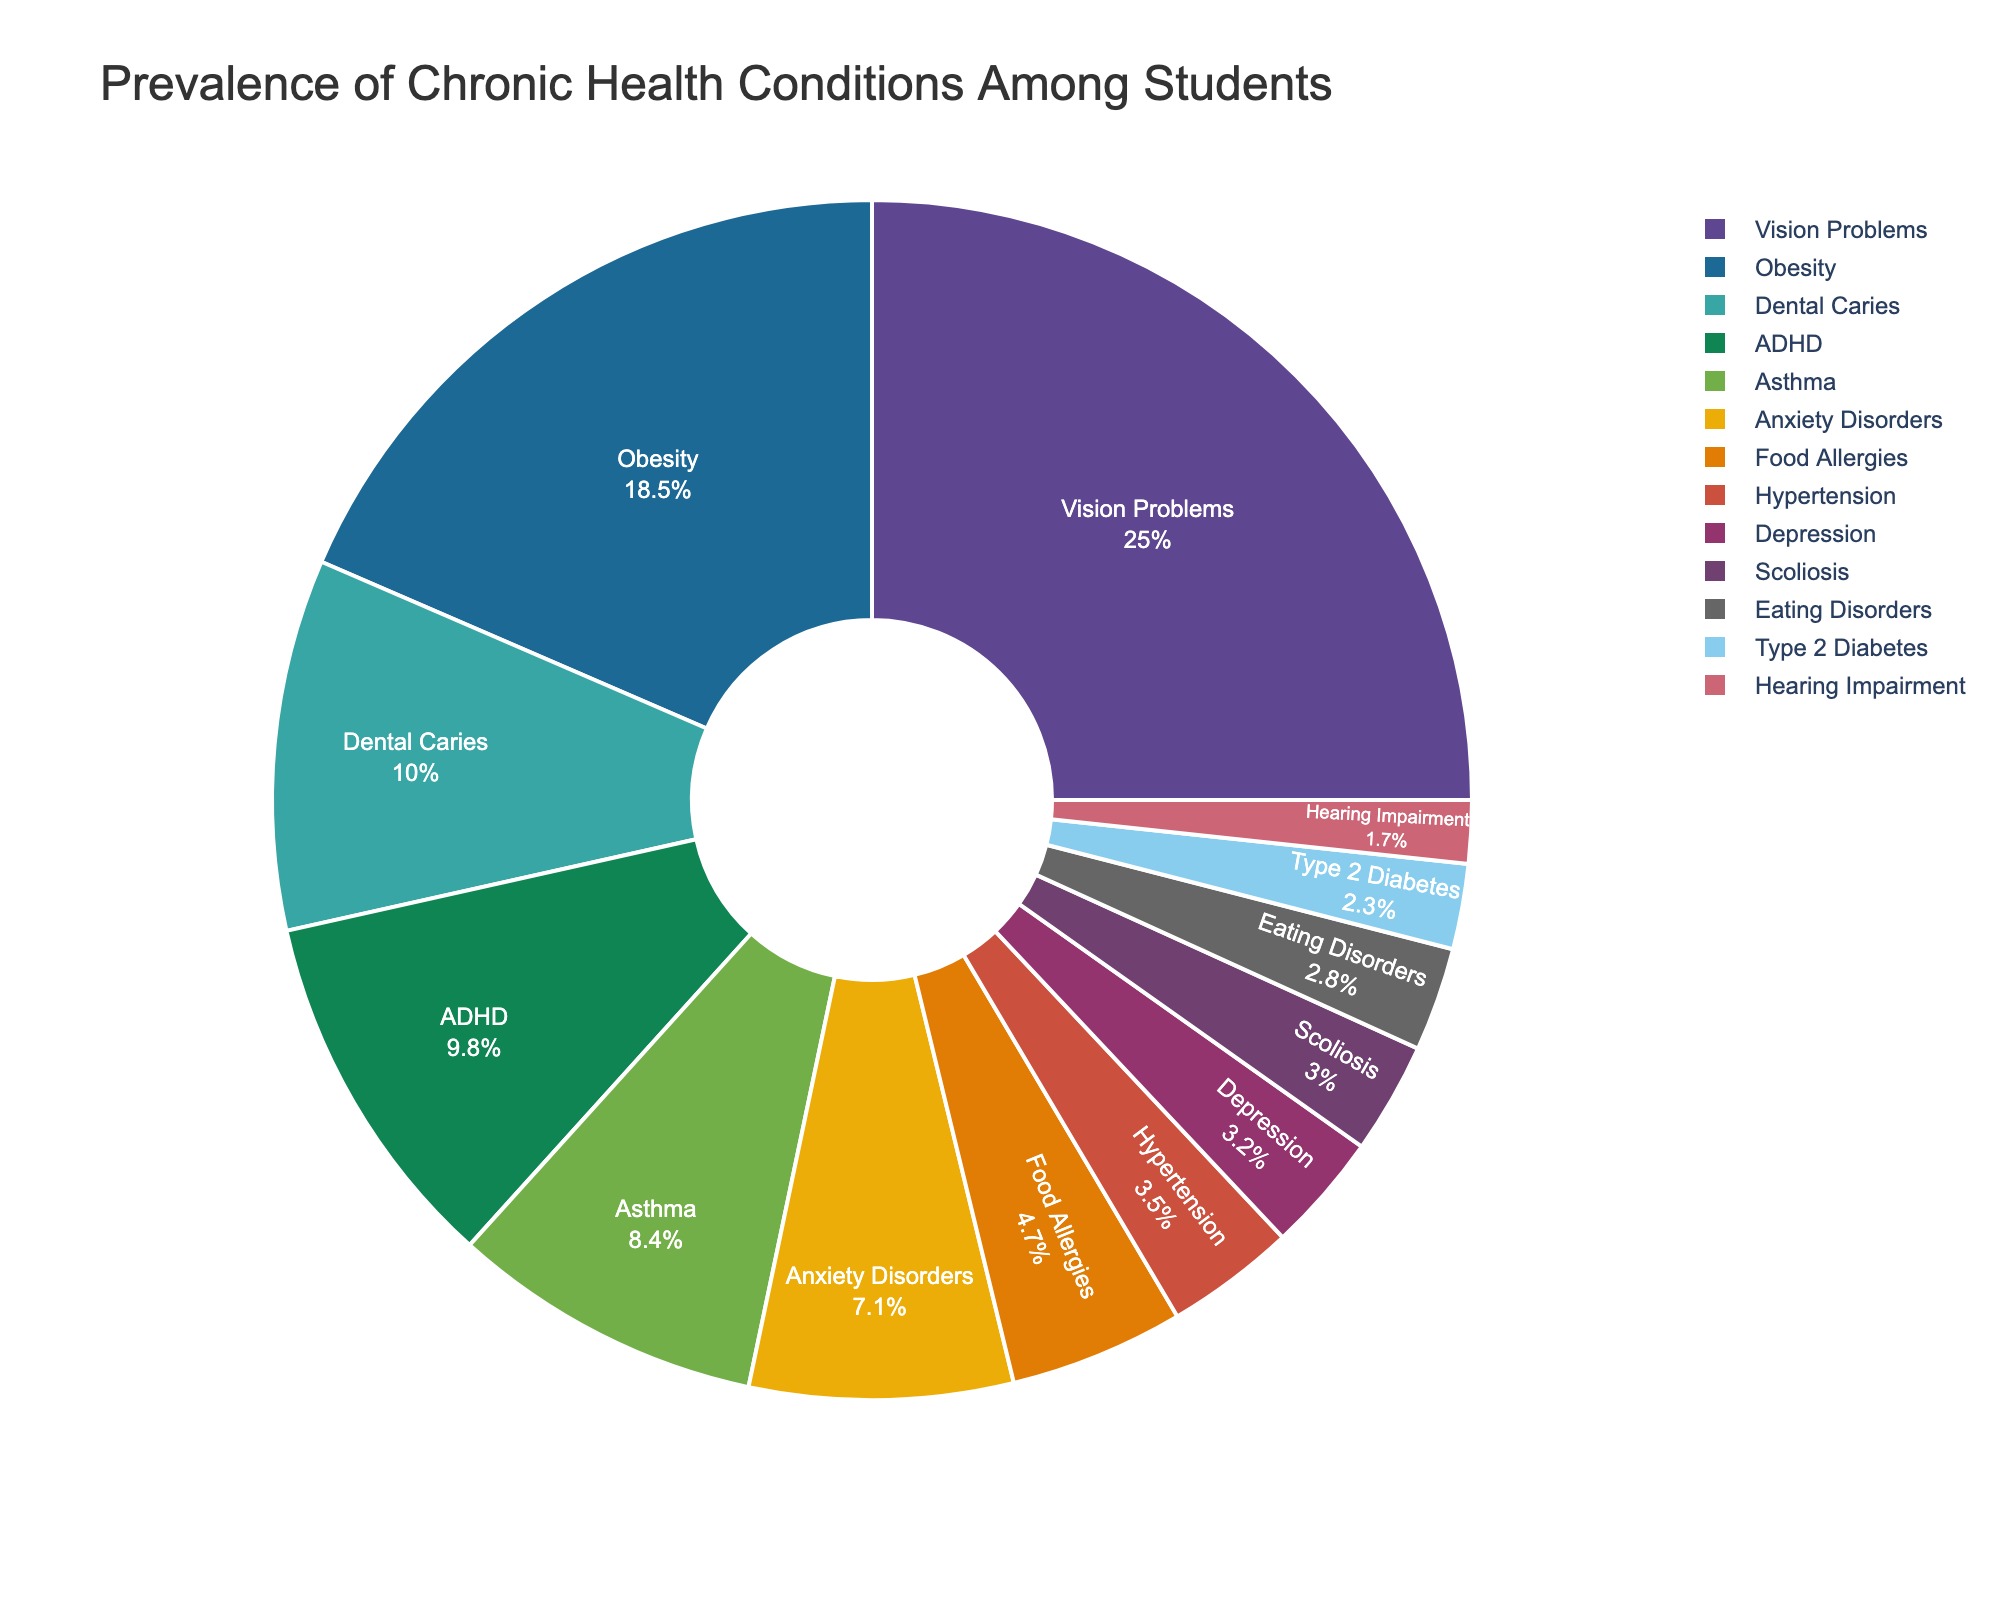Which health condition has the highest prevalence among students? The pie chart shows that the largest segment corresponds to Vision Problems with 25% of the total.
Answer: Vision Problems What is the combined prevalence of Asthma and ADHD among students? The prevalence of Asthma is 8.4% and ADHD is 9.8%. Adding these together results in 8.4 + 9.8 = 18.2%.
Answer: 18.2% Which two conditions have a combined prevalence closest to the prevalence of Obesity? Obesity has a prevalence of 18.5%. The combined prevalence of Anxiety Disorders (7.1%) and Dental Caries (10.0%) is 7.1 + 10.0 = 17.1%, which is closest to 18.5 when compared to other combinations.
Answer: Anxiety Disorders and Dental Caries How much greater is the prevalence of Vision Problems compared to the prevalence of Dental Caries? The prevalence of Vision Problems is 25%, and Dental Caries is 10%. The difference is 25 - 10 = 15%.
Answer: 15% What is the average prevalence of the three least common conditions? The least common conditions are Hearing Impairment (1.7%), Type 2 Diabetes (2.3%), and Eating Disorders (2.8%). The average is (1.7 + 2.3 + 2.8) / 3 = 6.8 / 3 ≈ 2.27%.
Answer: 2.27% Which condition has a prevalence closest to the midpoint (median) of the listed percentages? To find the median, we sort the percentages and find the middle value. The sorted percentages are: 1.7, 2.3, 2.8, 3.0, 3.2, 3.5, 4.7, 7.1, 8.4, 9.8, 10.0, 18.5, 25.0. The middle value is 4.7, corresponding to Food Allergies.
Answer: Food Allergies Do Anxiety Disorders have a higher prevalence than Depression? Yes, the pie chart shows Anxiety Disorders at 7.1% and Depression at 3.2%, indicating Anxiety Disorders have a higher prevalence.
Answer: Yes What is the sum of the prevalences of all conditions greater than 5%? The conditions are Vision Problems (25.0%), Obesity (18.5%), Dental Caries (10.0%), ADHD (9.8%), and Asthma (8.4%), Anxiety Disorders (7.1%). The sum is 25.0 + 18.5 + 10.0 + 9.8 + 8.4 + 7.1 = 78.8%.
Answer: 78.8% What proportion of the pie chart does Obesity occupy in comparison to Type 2 Diabetes? Obesity has a prevalence of 18.5%, and Type 2 Diabetes has a prevalence of 2.3%. The ratio is 18.5 / 2.3 ≈ 8.04, meaning Obesity's slice is about 8 times larger than Type 2 Diabetes.
Answer: ~8 times 